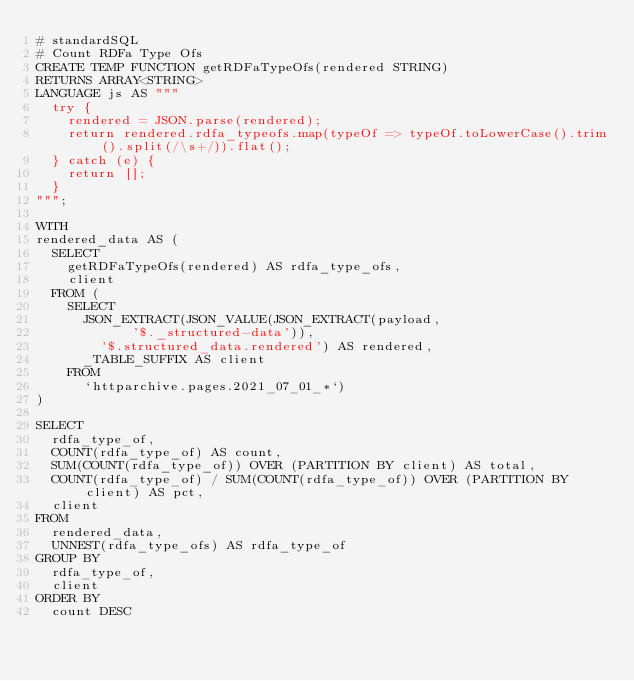Convert code to text. <code><loc_0><loc_0><loc_500><loc_500><_SQL_># standardSQL
# Count RDFa Type Ofs
CREATE TEMP FUNCTION getRDFaTypeOfs(rendered STRING)
RETURNS ARRAY<STRING>
LANGUAGE js AS """
  try {
    rendered = JSON.parse(rendered);
    return rendered.rdfa_typeofs.map(typeOf => typeOf.toLowerCase().trim().split(/\s+/)).flat();
  } catch (e) {
    return [];
  }
""";

WITH
rendered_data AS (
  SELECT
    getRDFaTypeOfs(rendered) AS rdfa_type_ofs,
    client
  FROM (
    SELECT
      JSON_EXTRACT(JSON_VALUE(JSON_EXTRACT(payload,
            '$._structured-data')),
        '$.structured_data.rendered') AS rendered,
      _TABLE_SUFFIX AS client
    FROM
      `httparchive.pages.2021_07_01_*`)
)

SELECT
  rdfa_type_of,
  COUNT(rdfa_type_of) AS count,
  SUM(COUNT(rdfa_type_of)) OVER (PARTITION BY client) AS total,
  COUNT(rdfa_type_of) / SUM(COUNT(rdfa_type_of)) OVER (PARTITION BY client) AS pct,
  client
FROM
  rendered_data,
  UNNEST(rdfa_type_ofs) AS rdfa_type_of
GROUP BY
  rdfa_type_of,
  client
ORDER BY
  count DESC
</code> 